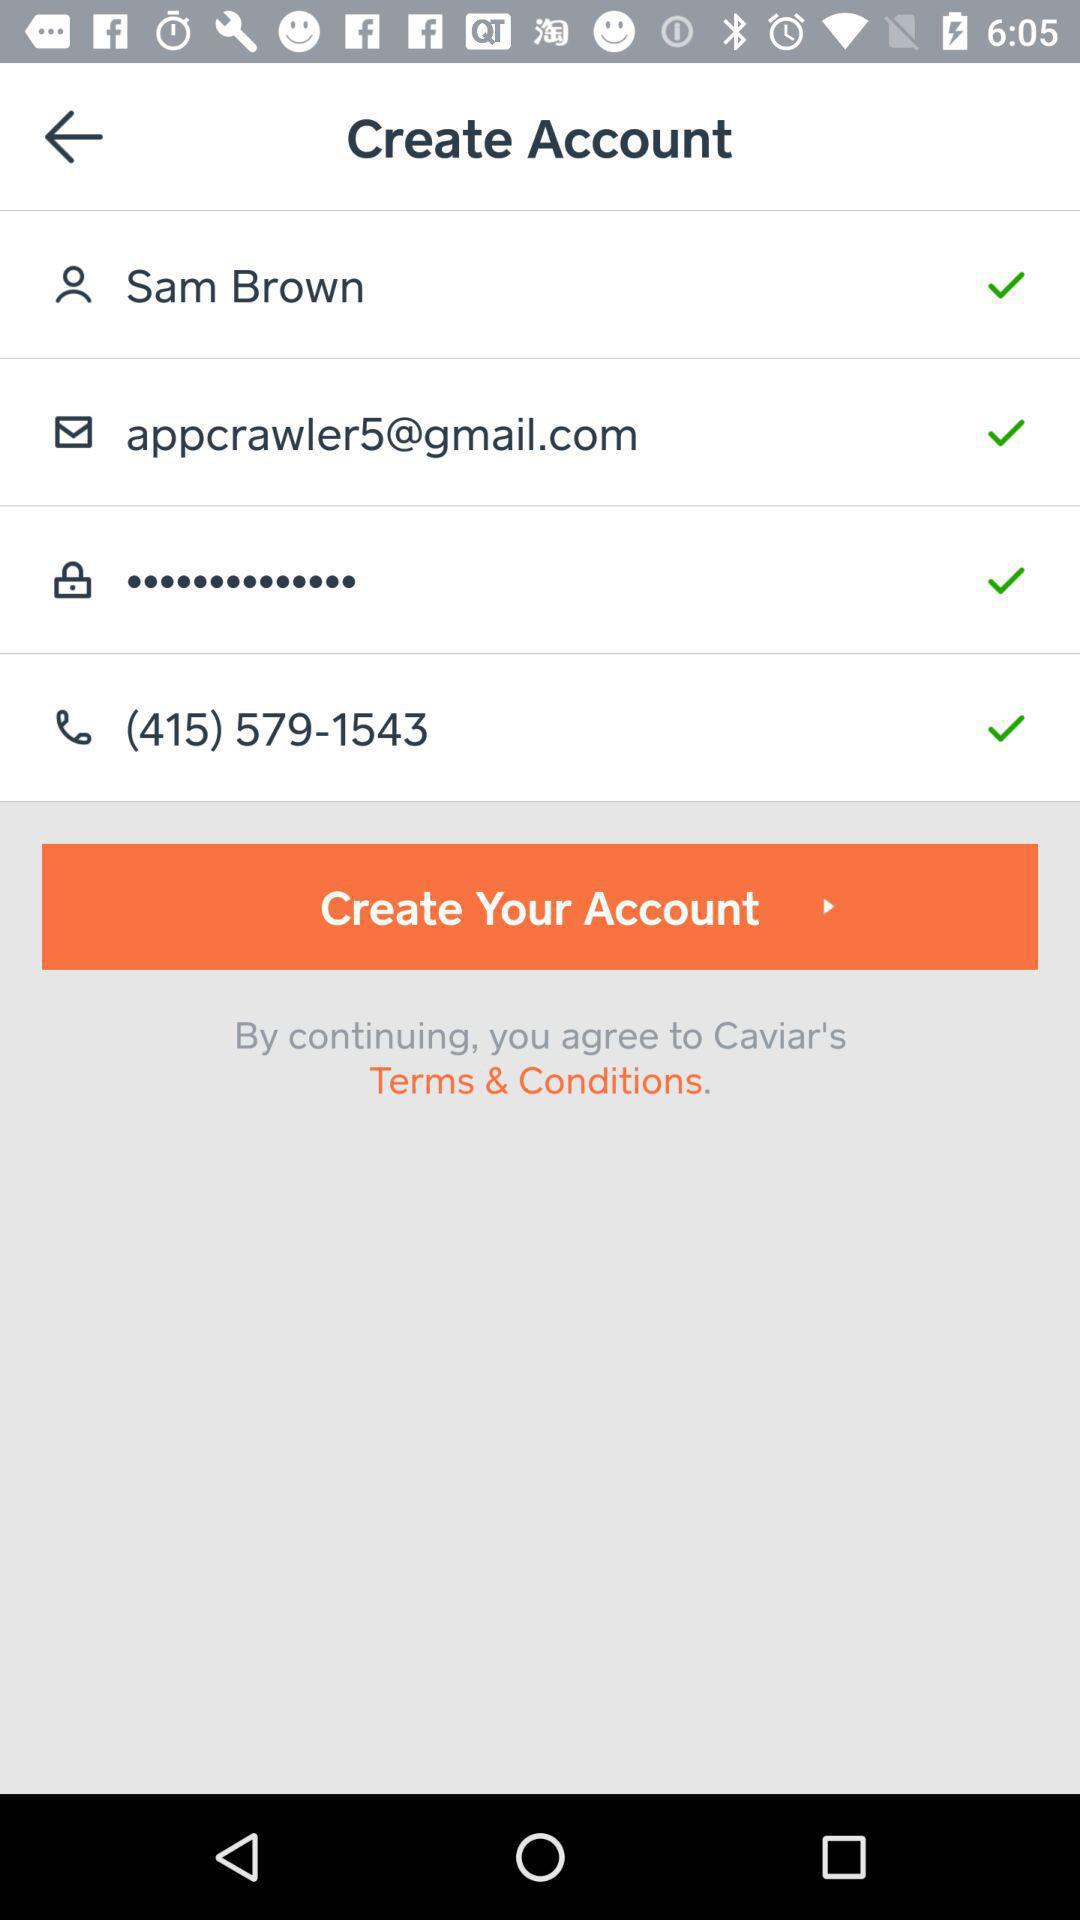What is the email address? The email address is appcrawler5@gmail.com. 